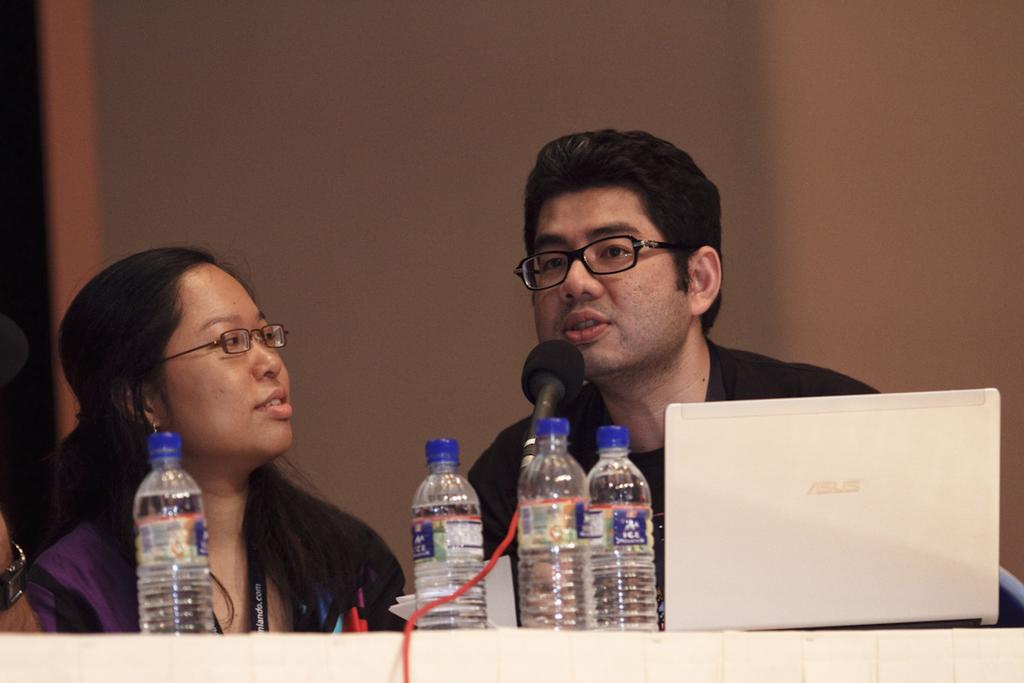Who are the people in the image? There is a man and a woman seated in the image. What objects are on the table in the image? There is a laptop and water bottles on the table. What is the man doing in the image? A man is speaking with the help of a microphone. How many goats are present in the image? There are no goats present in the image. What type of eggs can be seen in the image? There are no eggs present in the image. 